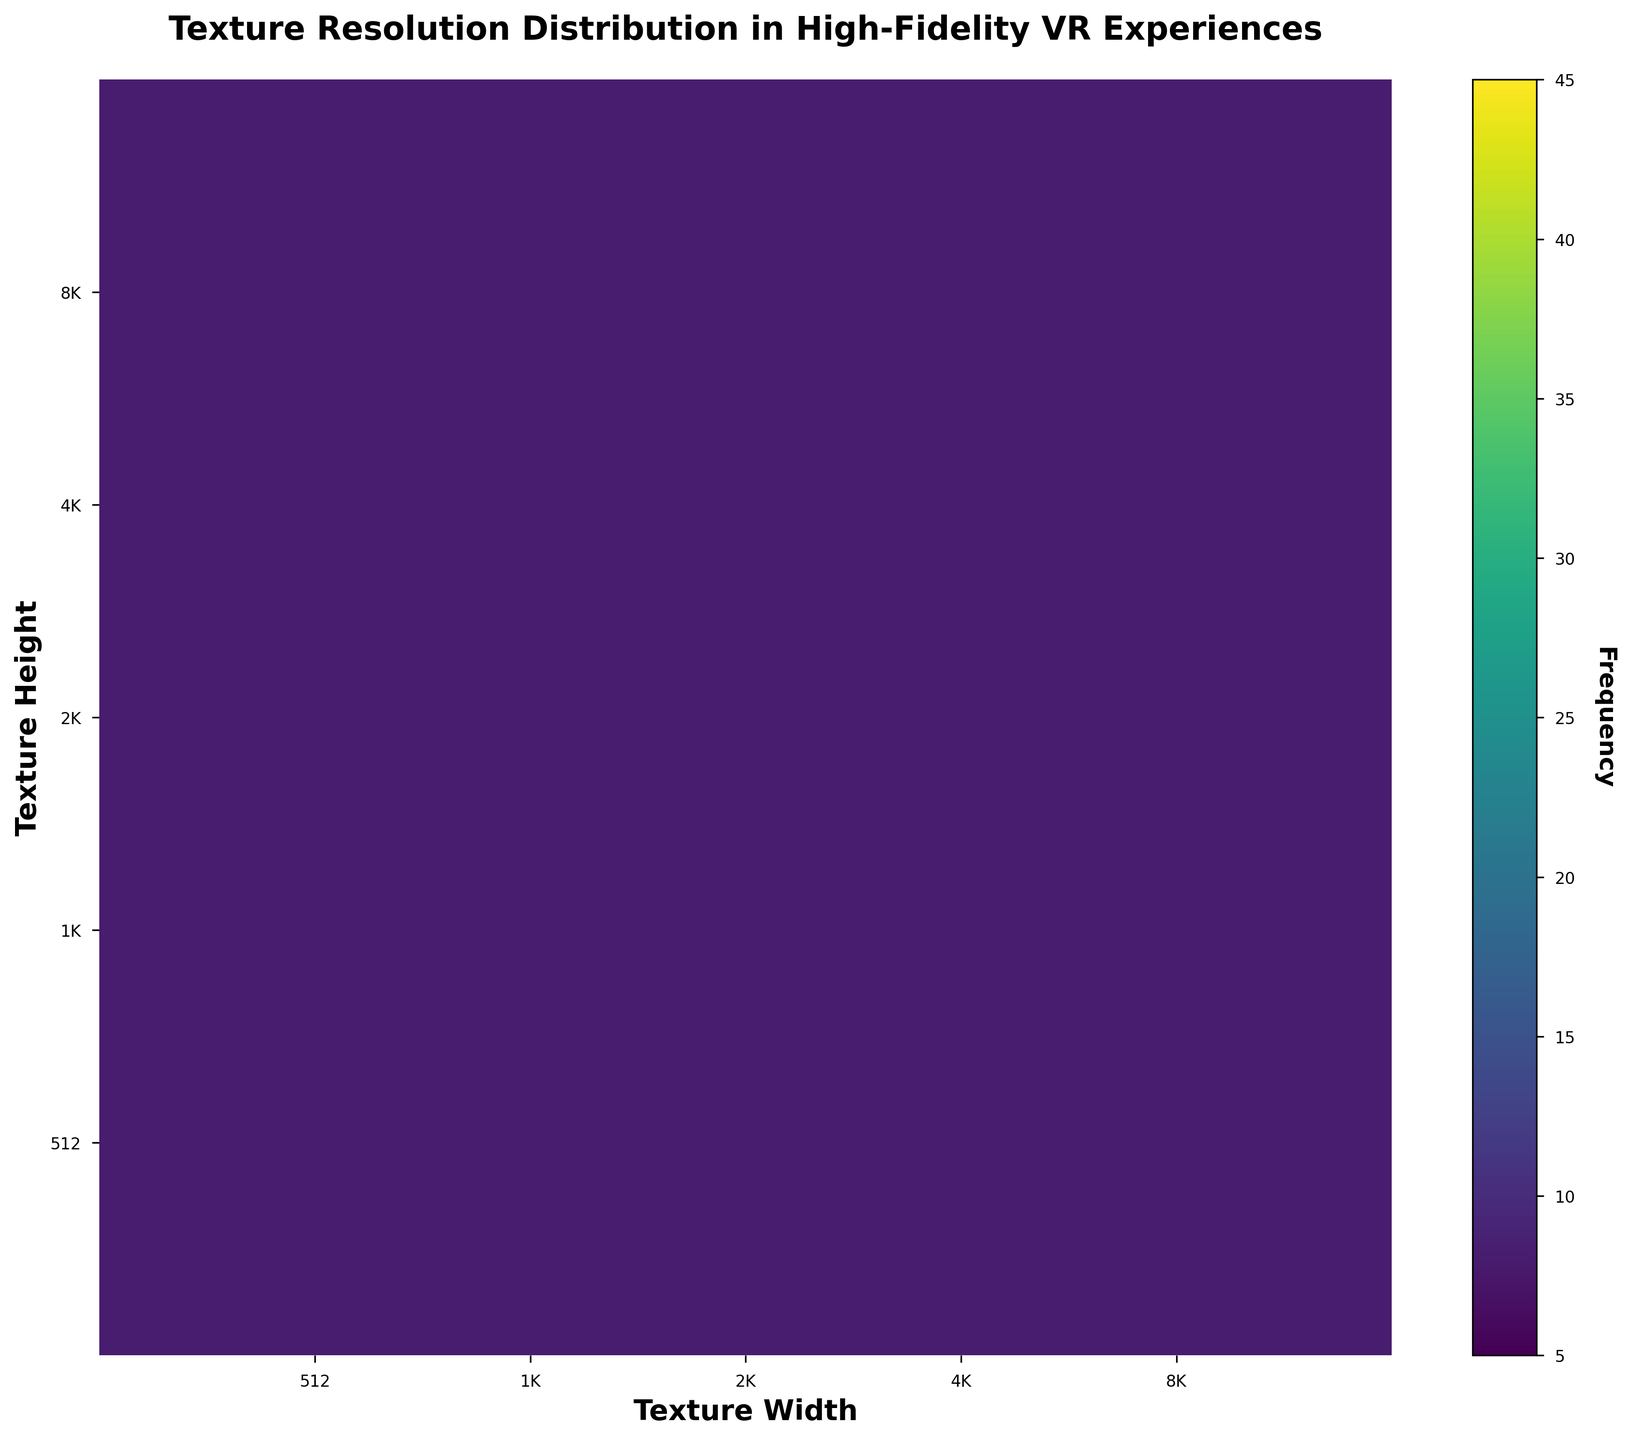What is the title of the figure? The title of the figure is displayed at the top, centered and in bold text. It reads "Texture Resolution Distribution in High-Fidelity VR Experiences".
Answer: "Texture Resolution Distribution in High-Fidelity VR Experiences" What are the labels on the x and y axes? The x-axis label reads "Texture Width" and the y-axis label reads "Texture Height." These labels are in bold text and positioned below the x-axis and to the left of the y-axis, respectively.
Answer: "Texture Width" and "Texture Height" What is the color map used in the figure? The color map used to represent the frequency in the hexbin plot ranges from light yellow to dark blue, indicating different levels of frequency. The information to infer this is found in the plot and the associated color bar.
Answer: "Viridis" Which texture resolution has the highest frequency? By observing the hexbin plot and the corresponding color intensity, the (2048, 2048) resolution has the highest frequency because it has the darkest shade of blue, indicating a high frequency of 45.
Answer: (2048, 2048) How many texture resolutions have a frequency higher than 30? To determine this, count each hexbin where the color intensity suggests a frequency higher than 30. These include (2048, 2048) with 45 and (4096, 4096) with 32. Hence, there are 2 such resolutions.
Answer: 2 What is the unique feature of the scales used for the x and y axes? The unique feature of the axes is that both are logarithmic scales with a base of 2, as indicated by the ticks and labels (512, 1024, 2048, 4096, 8192), and they span from 256 to 16384.
Answer: Logarithmic with base 2 Which pair of texture resolutions (width and height) has exactly 25 occurrences? The pair (4096, 2048) is identified to have exactly 25 occurrences, as indicated by the specific shade of blue in the hexbin plot.
Answer: (4096, 2048) How does the frequency of the resolution (1024, 1024) compare to (4096, 1024)? Comparing the color intensities, (1024, 1024) with a frequency of 28 has a higher frequency than (4096, 1024), which has a frequency of 14.
Answer: (1024, 1024) has a higher frequency What can you infer about the distribution of texture resolutions in the VR experiences? Observing the color intensities and distribution, most texture resolutions fall within the mid-range sizes (1024x1024 to 4096x4096) with higher frequencies in these areas, while very high and very low resolutions are less frequent.
Answer: Most are mid-range sizes What is the frequency of the resolution (8192, 4096)? By identifying the corresponding color and intensity in the hexbin plot, (8192, 4096) has a frequency of 11.
Answer: 11 